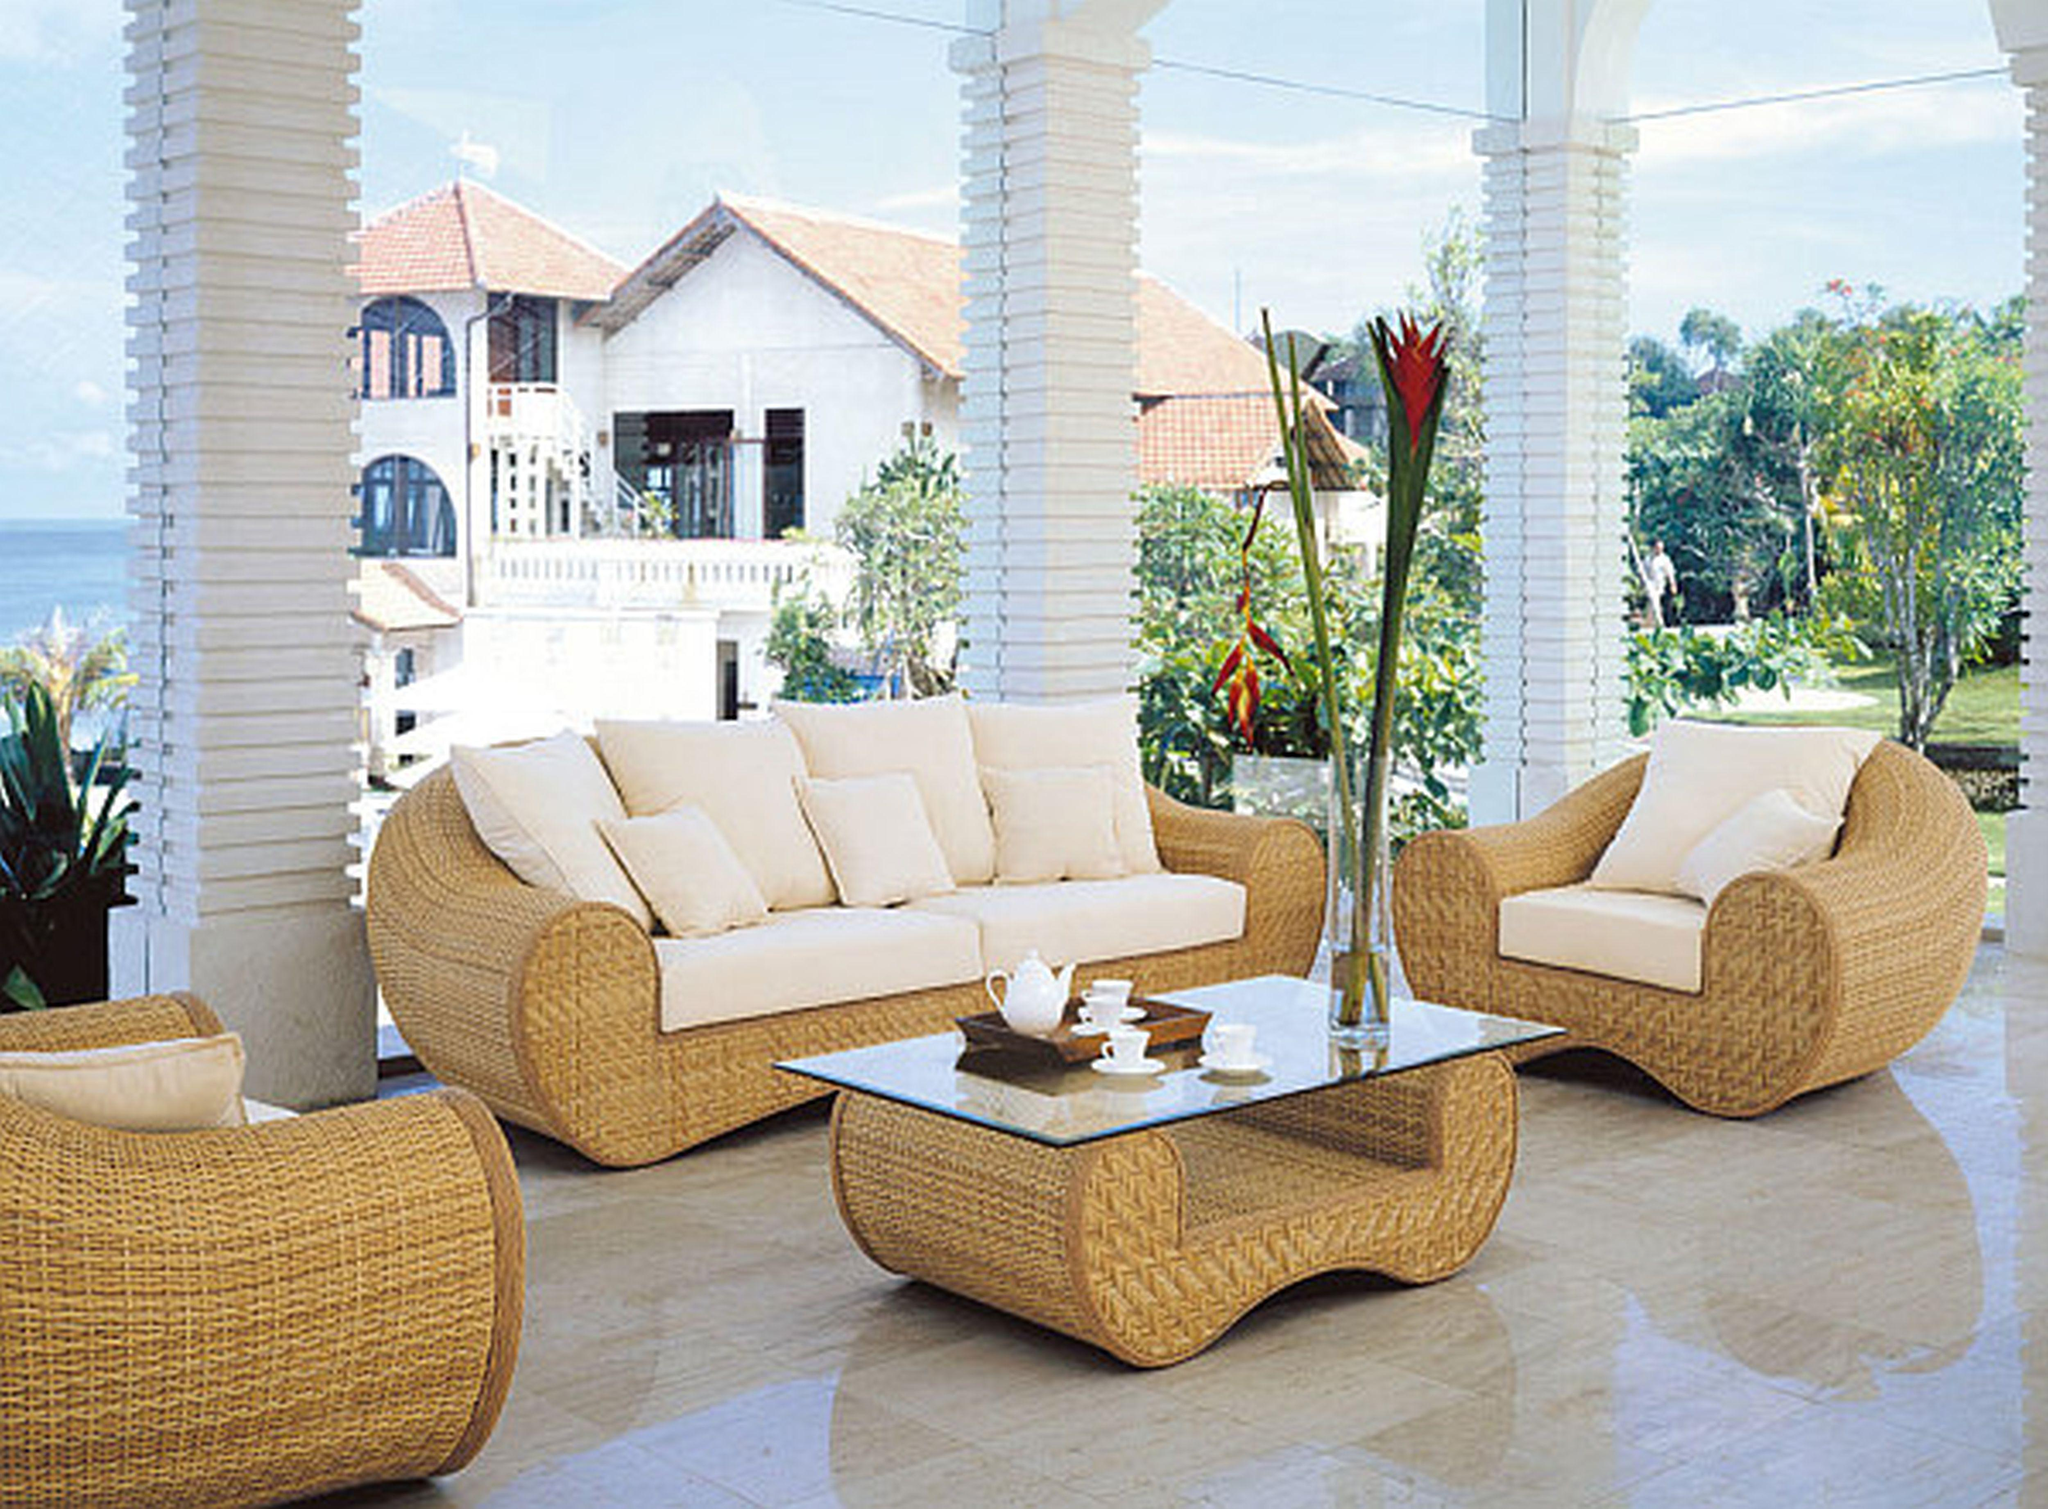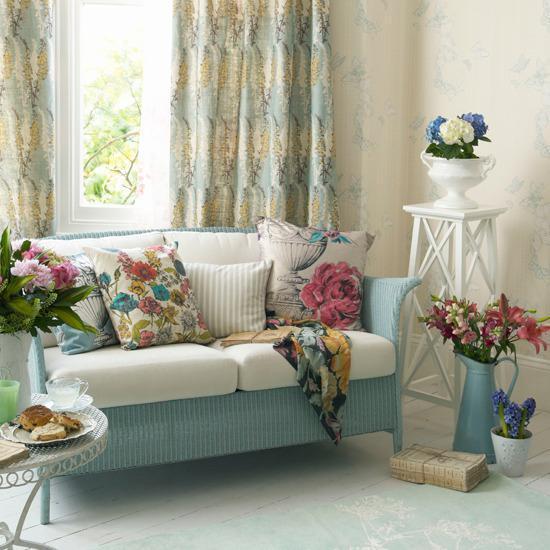The first image is the image on the left, the second image is the image on the right. Given the left and right images, does the statement "The pillows in the left image match the sofa." hold true? Answer yes or no. Yes. The first image is the image on the left, the second image is the image on the right. Assess this claim about the two images: "there are white columns behind a sofa". Correct or not? Answer yes or no. Yes. 